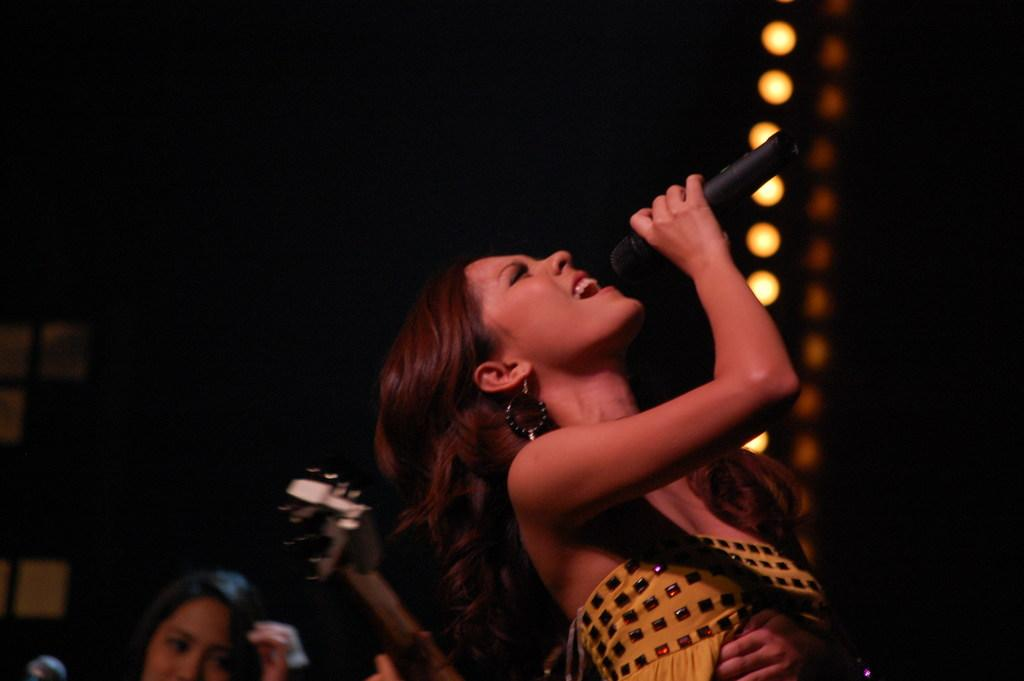Who is the main subject in the image? There is a girl in the image. What is the girl holding in the image? The girl is holding a microphone. What is the girl doing in the image? The girl is singing. What type of sand can be seen in the background of the image? There is no sand present in the image; it features a girl holding a microphone and singing. 